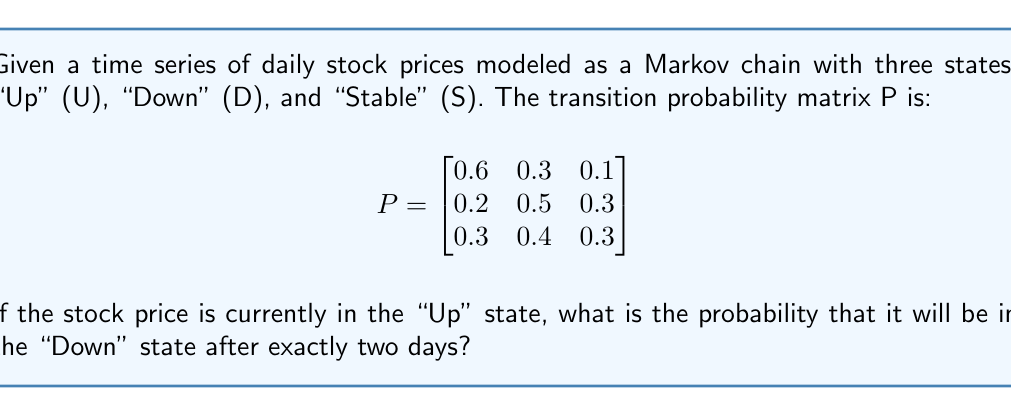Could you help me with this problem? To solve this problem, we need to use the Chapman-Kolmogorov equations and calculate the two-step transition probability. Let's break it down step-by-step:

1. We start in the "Up" state (U) and want to end in the "Down" state (D) after two steps.

2. We need to calculate $P_{UD}^{(2)}$, which is the probability of going from U to D in exactly two steps.

3. The formula for this is:

   $P_{UD}^{(2)} = P_{UU}P_{UD} + P_{UD}P_{DD} + P_{US}P_{SD}$

   Where:
   - $P_{UU}$ is the probability of going from U to U in one step
   - $P_{UD}$ is the probability of going from U to D in one step
   - $P_{US}$ is the probability of going from U to S in one step
   - $P_{DD}$ is the probability of going from D to D in one step
   - $P_{SD}$ is the probability of going from S to D in one step

4. From the given transition probability matrix:
   $P_{UU} = 0.6$
   $P_{UD} = 0.3$
   $P_{US} = 0.1$
   $P_{DD} = 0.5$
   $P_{SD} = 0.4$

5. Now, let's substitute these values into our equation:

   $P_{UD}^{(2)} = (0.6 \times 0.3) + (0.3 \times 0.5) + (0.1 \times 0.4)$

6. Calculate each term:
   $0.6 \times 0.3 = 0.18$
   $0.3 \times 0.5 = 0.15$
   $0.1 \times 0.4 = 0.04$

7. Sum up the terms:

   $P_{UD}^{(2)} = 0.18 + 0.15 + 0.04 = 0.37$

Therefore, the probability that the stock price will be in the "Down" state after exactly two days, given that it starts in the "Up" state, is 0.37 or 37%.
Answer: 0.37 